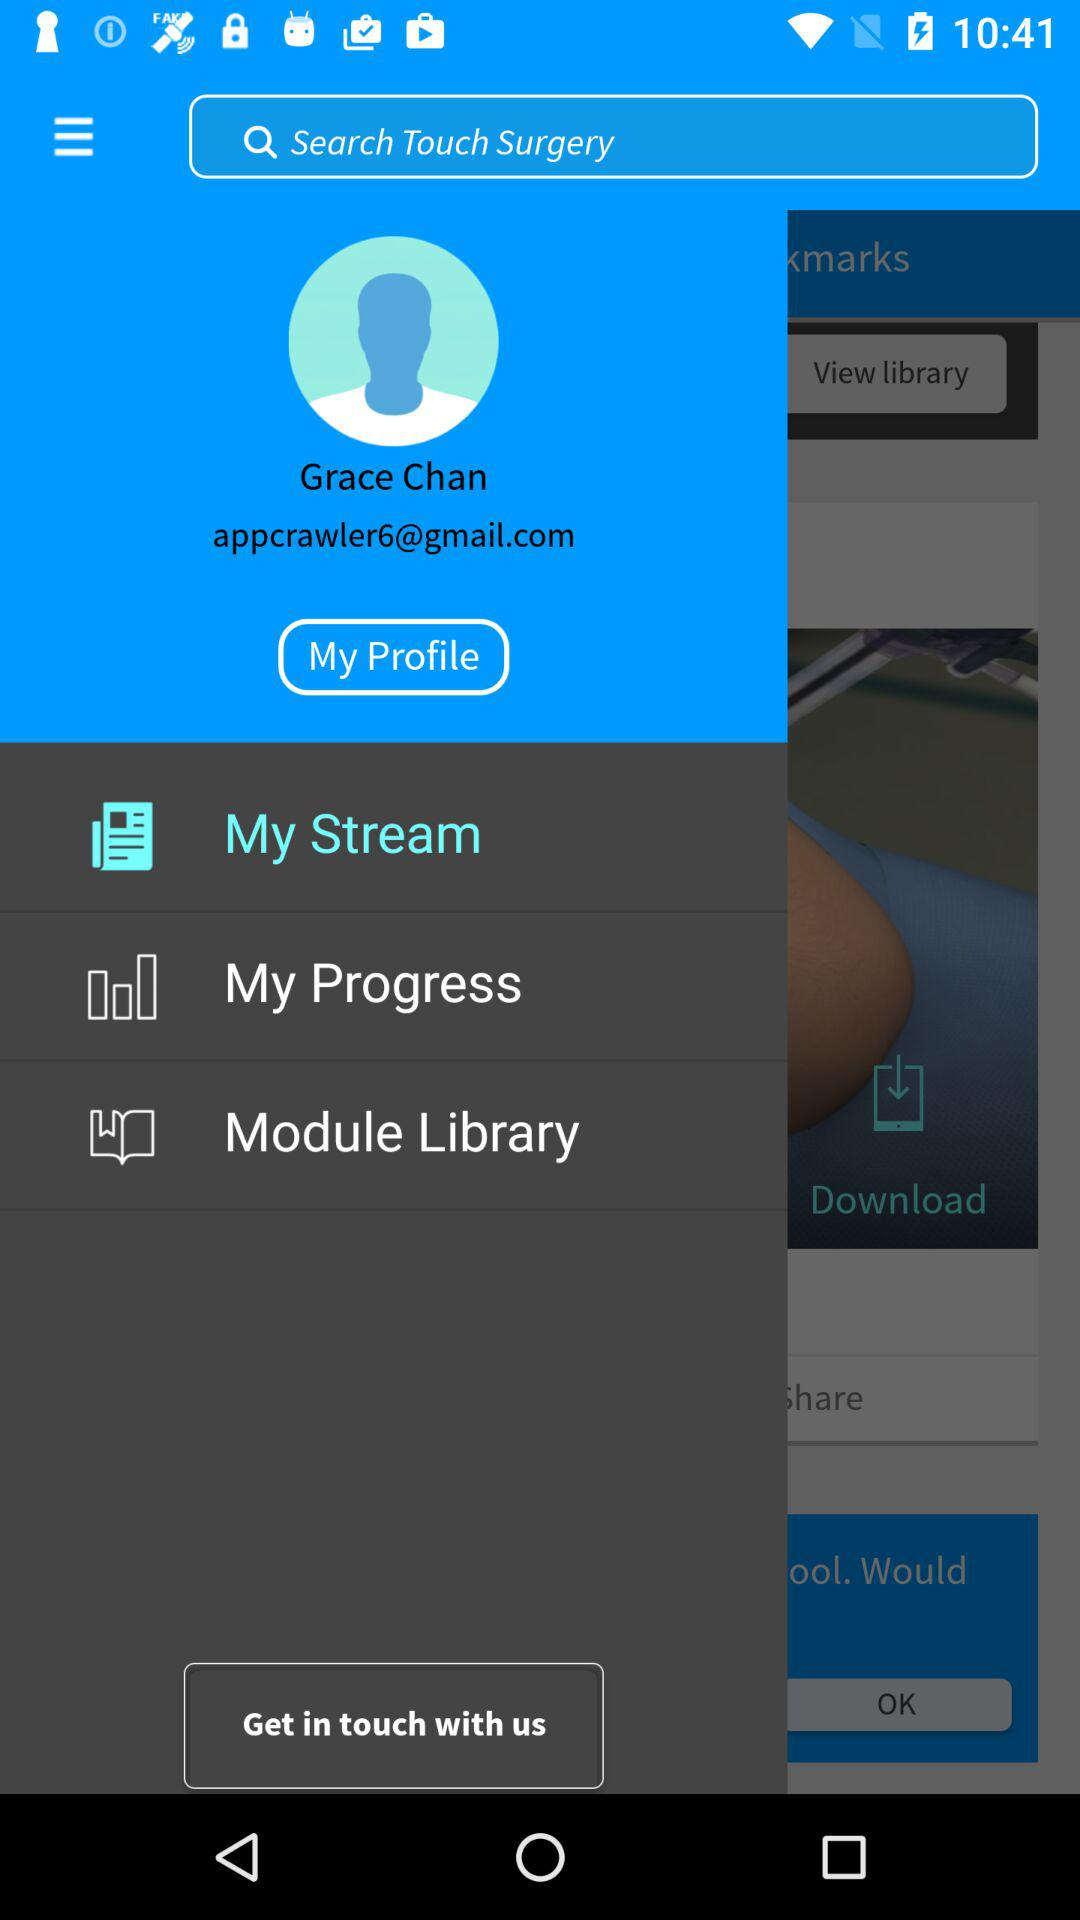What is the username? The username is Grace Chan. 